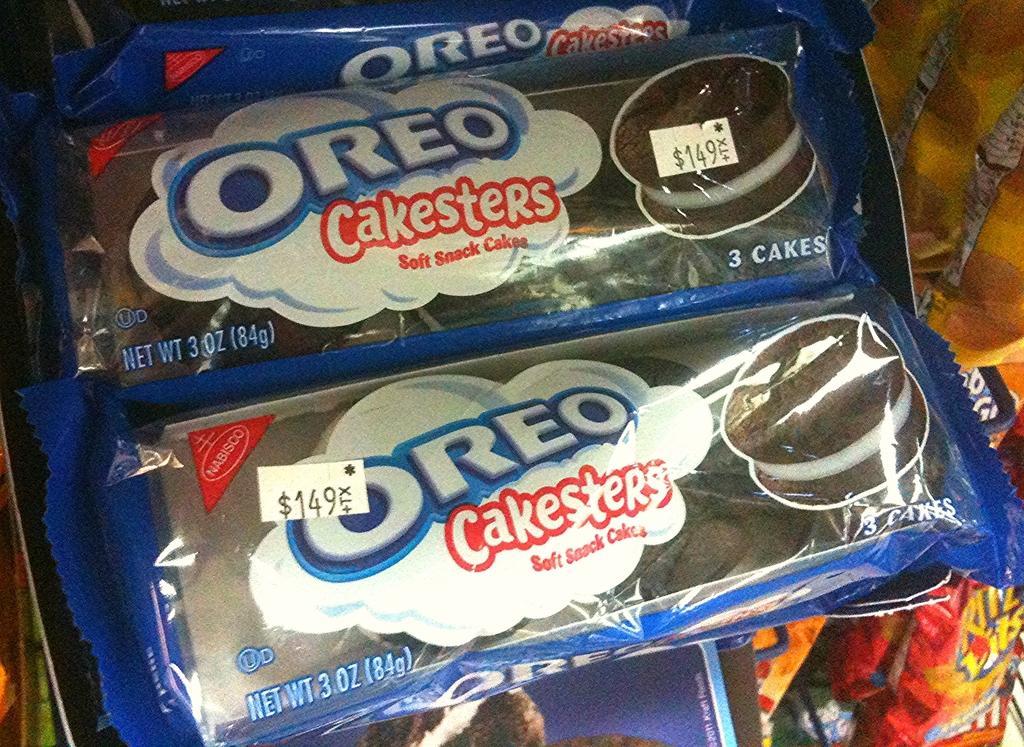Could you give a brief overview of what you see in this image? In this image I can see cake packets and covers may be on a stand. This image is taken may be in a shop. 